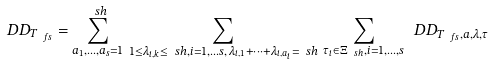<formula> <loc_0><loc_0><loc_500><loc_500>\ D D _ { T _ { \ f s } } = \sum _ { a _ { 1 } , \dots , a _ { s } = 1 } ^ { \ s h } \, \sum _ { 1 \leq \lambda _ { i , k } \leq \ s h , i = 1 , \dots s , \, \lambda _ { i , 1 } + \dots + \lambda _ { i , a _ { i } } = \ s h } \, \sum _ { \tau _ { i } \in \Xi _ { \ s h } , i = 1 , \dots , s } \ D D _ { T _ { \ f s } , a , \lambda , \tau }</formula> 